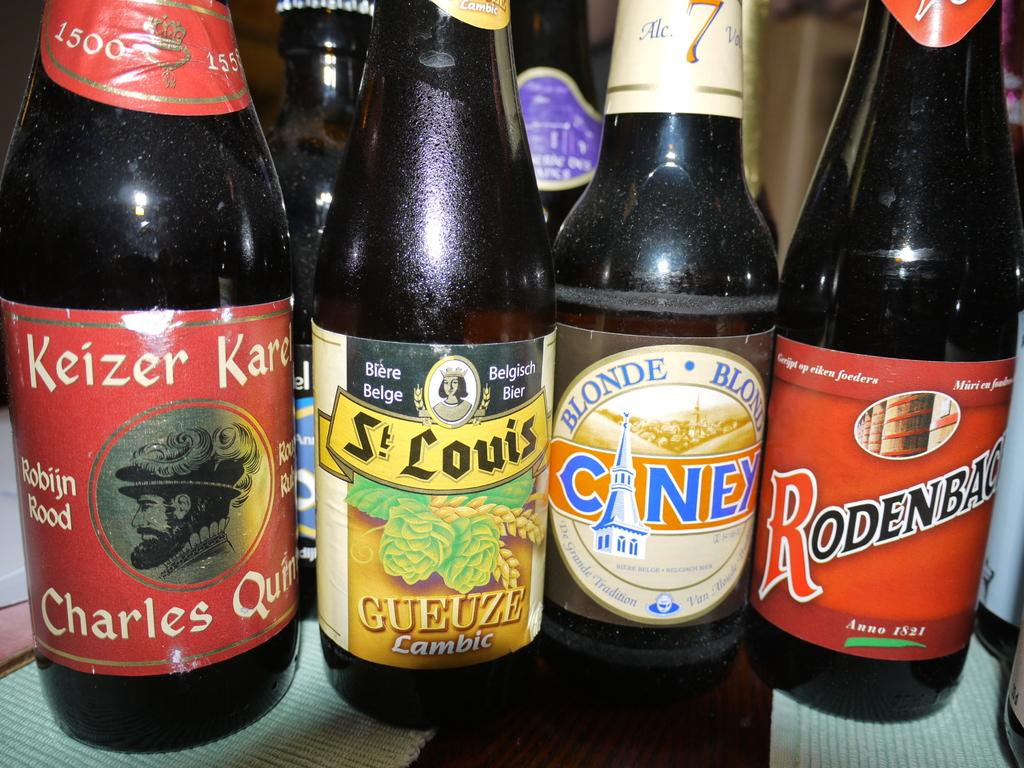What objects are present in the image? There are bottles in the image. What can be inferred about the bottles' location? The bottles are on an object. What type of lettuce is being served for dinner in the image? There is no lettuce or dinner present in the image; it only features bottles on an object. 